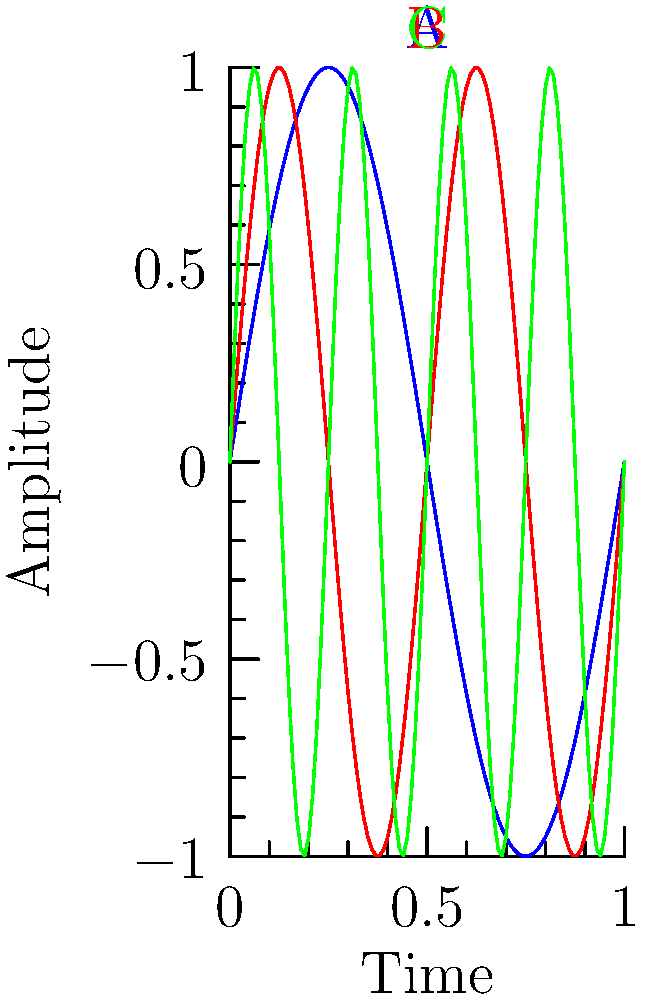The image shows three audio waveforms labeled A, B, and C. If waveform A represents a frequency of 440 Hz, what are the approximate frequencies of waveforms B and C? To solve this problem, let's follow these steps:

1. Observe the waveforms:
   - Waveform A (blue) completes 1 cycle in the given time period.
   - Waveform B (red) completes 2 cycles in the same time period.
   - Waveform C (green) completes 4 cycles in the same time period.

2. Establish the relationship:
   - The frequency of a waveform is directly proportional to the number of cycles completed in a given time period.
   - If A represents 440 Hz and completes 1 cycle, we can set up the following proportions:
     B frequency : A frequency = 2 : 1
     C frequency : A frequency = 4 : 1

3. Calculate the frequencies:
   - For waveform B:
     $f_B = 440 \text{ Hz} \times \frac{2}{1} = 880 \text{ Hz}$
   
   - For waveform C:
     $f_C = 440 \text{ Hz} \times \frac{4}{1} = 1760 \text{ Hz}$

Therefore, the approximate frequencies of waveforms B and C are 880 Hz and 1760 Hz, respectively.
Answer: B: 880 Hz, C: 1760 Hz 